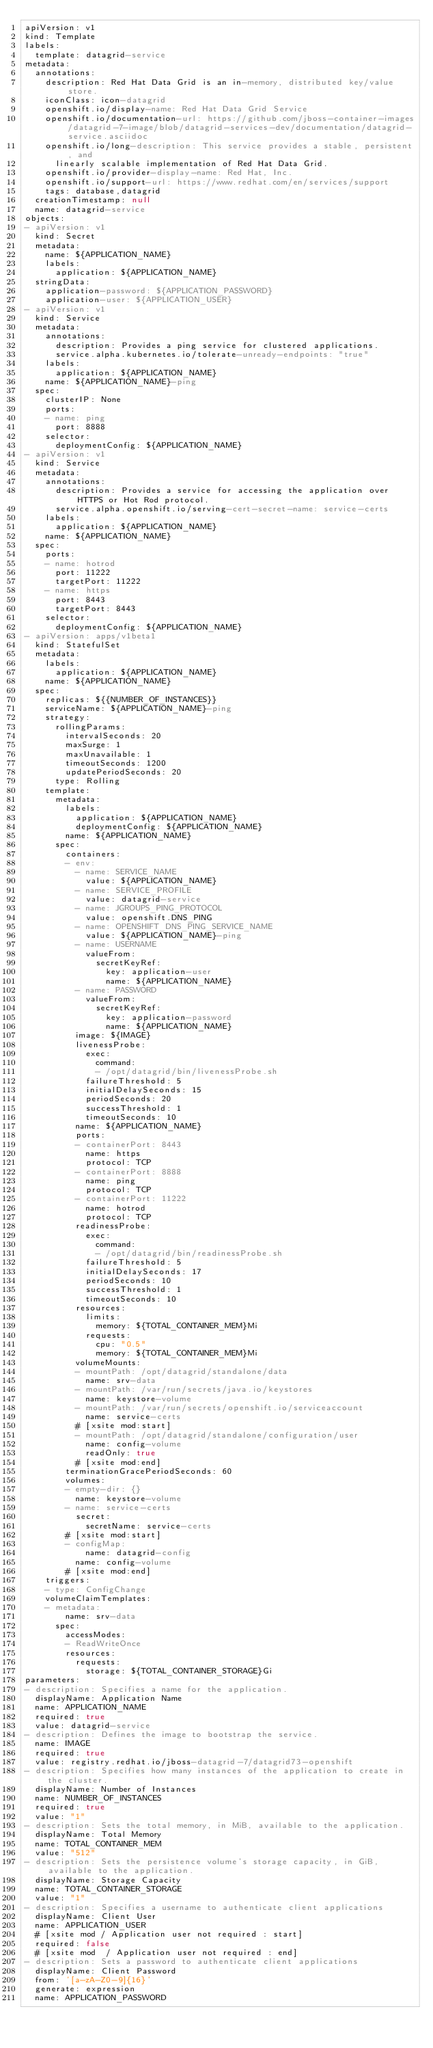<code> <loc_0><loc_0><loc_500><loc_500><_YAML_>apiVersion: v1
kind: Template
labels:
  template: datagrid-service
metadata:
  annotations:
    description: Red Hat Data Grid is an in-memory, distributed key/value store.
    iconClass: icon-datagrid
    openshift.io/display-name: Red Hat Data Grid Service
    openshift.io/documentation-url: https://github.com/jboss-container-images/datagrid-7-image/blob/datagrid-services-dev/documentation/datagrid-service.asciidoc
    openshift.io/long-description: This service provides a stable, persistent, and
      linearly scalable implementation of Red Hat Data Grid.
    openshift.io/provider-display-name: Red Hat, Inc.
    openshift.io/support-url: https://www.redhat.com/en/services/support
    tags: database,datagrid
  creationTimestamp: null
  name: datagrid-service
objects:
- apiVersion: v1
  kind: Secret
  metadata:
    name: ${APPLICATION_NAME}
    labels:
      application: ${APPLICATION_NAME}
  stringData:
    application-password: ${APPLICATION_PASSWORD}
    application-user: ${APPLICATION_USER}
- apiVersion: v1
  kind: Service
  metadata:
    annotations:
      description: Provides a ping service for clustered applications.
      service.alpha.kubernetes.io/tolerate-unready-endpoints: "true"
    labels:
      application: ${APPLICATION_NAME}
    name: ${APPLICATION_NAME}-ping
  spec:
    clusterIP: None
    ports:
    - name: ping
      port: 8888
    selector:
      deploymentConfig: ${APPLICATION_NAME}
- apiVersion: v1
  kind: Service
  metadata:
    annotations:
      description: Provides a service for accessing the application over HTTPS or Hot Rod protocol.
      service.alpha.openshift.io/serving-cert-secret-name: service-certs
    labels:
      application: ${APPLICATION_NAME}
    name: ${APPLICATION_NAME}
  spec:
    ports:
    - name: hotrod
      port: 11222
      targetPort: 11222
    - name: https
      port: 8443
      targetPort: 8443
    selector:
      deploymentConfig: ${APPLICATION_NAME}
- apiVersion: apps/v1beta1
  kind: StatefulSet
  metadata:
    labels:
      application: ${APPLICATION_NAME}
    name: ${APPLICATION_NAME}
  spec:
    replicas: ${{NUMBER_OF_INSTANCES}}
    serviceName: ${APPLICATION_NAME}-ping
    strategy:
      rollingParams:
        intervalSeconds: 20
        maxSurge: 1
        maxUnavailable: 1
        timeoutSeconds: 1200
        updatePeriodSeconds: 20
      type: Rolling
    template:
      metadata:
        labels:
          application: ${APPLICATION_NAME}
          deploymentConfig: ${APPLICATION_NAME}
        name: ${APPLICATION_NAME}
      spec:
        containers:
        - env:
          - name: SERVICE_NAME
            value: ${APPLICATION_NAME}
          - name: SERVICE_PROFILE
            value: datagrid-service
          - name: JGROUPS_PING_PROTOCOL
            value: openshift.DNS_PING
          - name: OPENSHIFT_DNS_PING_SERVICE_NAME
            value: ${APPLICATION_NAME}-ping
          - name: USERNAME
            valueFrom:
              secretKeyRef:
                key: application-user
                name: ${APPLICATION_NAME}
          - name: PASSWORD
            valueFrom:
              secretKeyRef:
                key: application-password
                name: ${APPLICATION_NAME}
          image: ${IMAGE}
          livenessProbe:
            exec:
              command:
              - /opt/datagrid/bin/livenessProbe.sh
            failureThreshold: 5
            initialDelaySeconds: 15
            periodSeconds: 20
            successThreshold: 1
            timeoutSeconds: 10
          name: ${APPLICATION_NAME}
          ports:
          - containerPort: 8443
            name: https
            protocol: TCP
          - containerPort: 8888
            name: ping
            protocol: TCP
          - containerPort: 11222
            name: hotrod
            protocol: TCP
          readinessProbe:
            exec:
              command:
              - /opt/datagrid/bin/readinessProbe.sh
            failureThreshold: 5
            initialDelaySeconds: 17
            periodSeconds: 10
            successThreshold: 1
            timeoutSeconds: 10
          resources:
            limits:
              memory: ${TOTAL_CONTAINER_MEM}Mi
            requests:
              cpu: "0.5"
              memory: ${TOTAL_CONTAINER_MEM}Mi
          volumeMounts:
          - mountPath: /opt/datagrid/standalone/data
            name: srv-data
          - mountPath: /var/run/secrets/java.io/keystores
            name: keystore-volume
          - mountPath: /var/run/secrets/openshift.io/serviceaccount
            name: service-certs
          # [xsite mod:start]
          - mountPath: /opt/datagrid/standalone/configuration/user
            name: config-volume
            readOnly: true
          # [xsite mod:end]
        terminationGracePeriodSeconds: 60
        volumes:
        - empty-dir: {}
          name: keystore-volume
        - name: service-certs
          secret:
            secretName: service-certs
        # [xsite mod:start]
        - configMap:
            name: datagrid-config
          name: config-volume
        # [xsite mod:end]
    triggers:
    - type: ConfigChange
    volumeClaimTemplates:
    - metadata:
        name: srv-data
      spec:
        accessModes:
        - ReadWriteOnce
        resources:
          requests:
            storage: ${TOTAL_CONTAINER_STORAGE}Gi
parameters:
- description: Specifies a name for the application.
  displayName: Application Name
  name: APPLICATION_NAME
  required: true
  value: datagrid-service
- description: Defines the image to bootstrap the service.
  name: IMAGE
  required: true
  value: registry.redhat.io/jboss-datagrid-7/datagrid73-openshift
- description: Specifies how many instances of the application to create in the cluster.
  displayName: Number of Instances
  name: NUMBER_OF_INSTANCES
  required: true
  value: "1"
- description: Sets the total memory, in MiB, available to the application.
  displayName: Total Memory
  name: TOTAL_CONTAINER_MEM
  value: "512"
- description: Sets the persistence volume's storage capacity, in GiB, available to the application.
  displayName: Storage Capacity
  name: TOTAL_CONTAINER_STORAGE
  value: "1"
- description: Specifies a username to authenticate client applications
  displayName: Client User
  name: APPLICATION_USER
  # [xsite mod / Application user not required : start]
  required: false
  # [xsite mod  / Application user not required : end]
- description: Sets a password to authenticate client applications
  displayName: Client Password
  from: '[a-zA-Z0-9]{16}'
  generate: expression
  name: APPLICATION_PASSWORD
</code> 